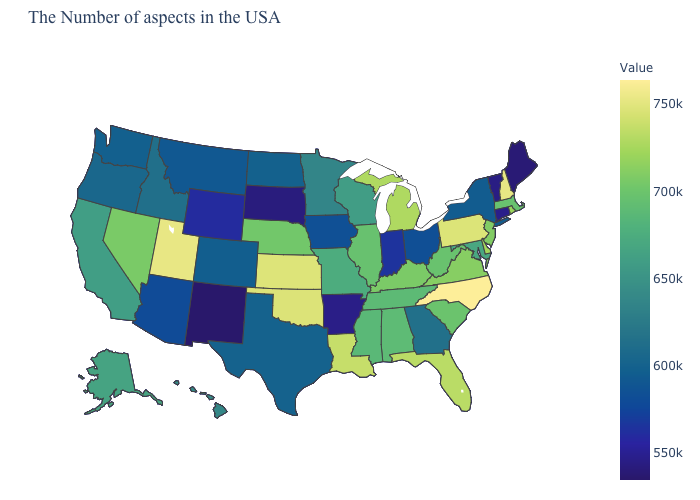Among the states that border Utah , which have the highest value?
Keep it brief. Nevada. Does Ohio have a higher value than Idaho?
Be succinct. No. Does Louisiana have the lowest value in the South?
Answer briefly. No. Does Georgia have the lowest value in the USA?
Keep it brief. No. Among the states that border Nevada , which have the highest value?
Write a very short answer. Utah. Among the states that border Massachusetts , which have the highest value?
Keep it brief. New Hampshire. 